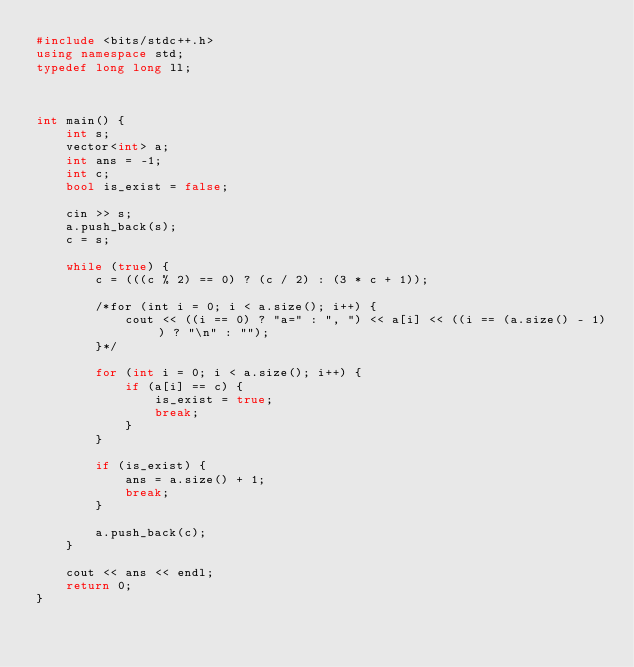Convert code to text. <code><loc_0><loc_0><loc_500><loc_500><_C++_>#include <bits/stdc++.h>
using namespace std;
typedef long long ll;



int main() {
    int s;
    vector<int> a;
    int ans = -1;
    int c;
    bool is_exist = false;
    
    cin >> s;
    a.push_back(s);
    c = s;
    
    while (true) {
        c = (((c % 2) == 0) ? (c / 2) : (3 * c + 1));
        
        /*for (int i = 0; i < a.size(); i++) {
            cout << ((i == 0) ? "a=" : ", ") << a[i] << ((i == (a.size() - 1)) ? "\n" : "");
        }*/
        
        for (int i = 0; i < a.size(); i++) {
            if (a[i] == c) {
                is_exist = true;
                break;
            }
        }
        
        if (is_exist) {
            ans = a.size() + 1;
            break;
        }
        
        a.push_back(c);
    }
    
    cout << ans << endl;
    return 0;
}</code> 